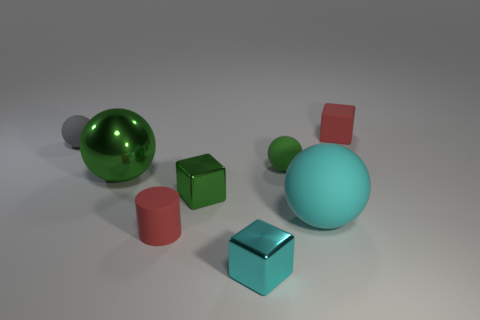Subtract all small green balls. How many balls are left? 3 How many green balls must be subtracted to get 1 green balls? 1 Subtract 1 cylinders. How many cylinders are left? 0 Subtract all brown cylinders. Subtract all brown spheres. How many cylinders are left? 1 Subtract all green spheres. How many cyan blocks are left? 1 Subtract all shiny cubes. Subtract all gray matte things. How many objects are left? 5 Add 8 small gray spheres. How many small gray spheres are left? 9 Add 6 small matte cylinders. How many small matte cylinders exist? 7 Add 1 tiny gray spheres. How many objects exist? 9 Subtract all green cubes. How many cubes are left? 2 